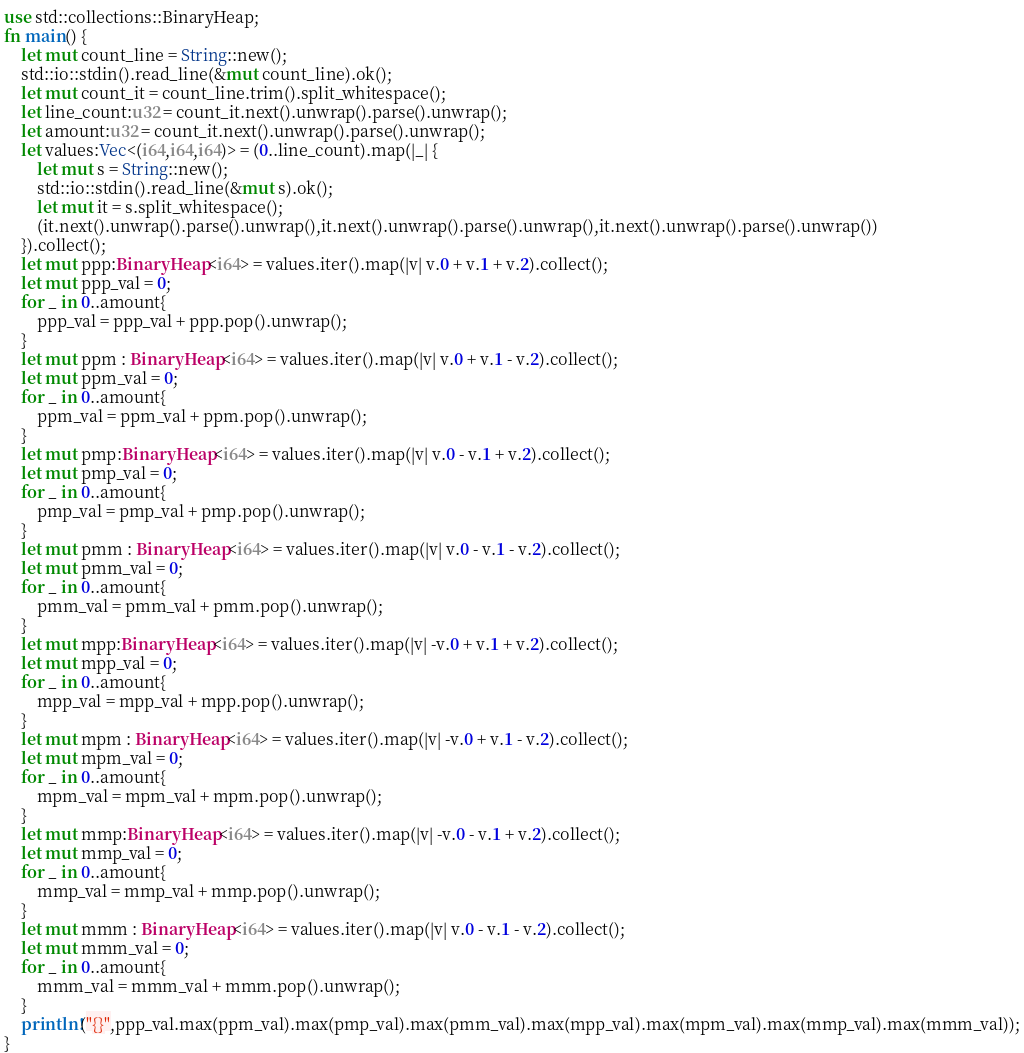Convert code to text. <code><loc_0><loc_0><loc_500><loc_500><_Rust_>use std::collections::BinaryHeap;
fn main() {
    let mut count_line = String::new();
    std::io::stdin().read_line(&mut count_line).ok();
    let mut count_it = count_line.trim().split_whitespace();
    let line_count:u32 = count_it.next().unwrap().parse().unwrap();
    let amount:u32 = count_it.next().unwrap().parse().unwrap();
    let values:Vec<(i64,i64,i64)> = (0..line_count).map(|_| {
        let mut s = String::new();
        std::io::stdin().read_line(&mut s).ok();
        let mut it = s.split_whitespace();
        (it.next().unwrap().parse().unwrap(),it.next().unwrap().parse().unwrap(),it.next().unwrap().parse().unwrap())
    }).collect();
    let mut ppp:BinaryHeap<i64> = values.iter().map(|v| v.0 + v.1 + v.2).collect();
    let mut ppp_val = 0;
    for _ in 0..amount{
        ppp_val = ppp_val + ppp.pop().unwrap();
    }
    let mut ppm : BinaryHeap<i64> = values.iter().map(|v| v.0 + v.1 - v.2).collect();
    let mut ppm_val = 0;
    for _ in 0..amount{
        ppm_val = ppm_val + ppm.pop().unwrap();
    }
    let mut pmp:BinaryHeap<i64> = values.iter().map(|v| v.0 - v.1 + v.2).collect();
    let mut pmp_val = 0;
    for _ in 0..amount{
        pmp_val = pmp_val + pmp.pop().unwrap();
    }
    let mut pmm : BinaryHeap<i64> = values.iter().map(|v| v.0 - v.1 - v.2).collect();
    let mut pmm_val = 0;
    for _ in 0..amount{
        pmm_val = pmm_val + pmm.pop().unwrap();
    }
    let mut mpp:BinaryHeap<i64> = values.iter().map(|v| -v.0 + v.1 + v.2).collect();
    let mut mpp_val = 0;
    for _ in 0..amount{
        mpp_val = mpp_val + mpp.pop().unwrap();
    }
    let mut mpm : BinaryHeap<i64> = values.iter().map(|v| -v.0 + v.1 - v.2).collect();
    let mut mpm_val = 0;
    for _ in 0..amount{
        mpm_val = mpm_val + mpm.pop().unwrap();
    }
    let mut mmp:BinaryHeap<i64> = values.iter().map(|v| -v.0 - v.1 + v.2).collect();
    let mut mmp_val = 0;
    for _ in 0..amount{
        mmp_val = mmp_val + mmp.pop().unwrap();
    }
    let mut mmm : BinaryHeap<i64> = values.iter().map(|v| v.0 - v.1 - v.2).collect();
    let mut mmm_val = 0;
    for _ in 0..amount{
        mmm_val = mmm_val + mmm.pop().unwrap();
    }
    println!("{}",ppp_val.max(ppm_val).max(pmp_val).max(pmm_val).max(mpp_val).max(mpm_val).max(mmp_val).max(mmm_val));
}
</code> 